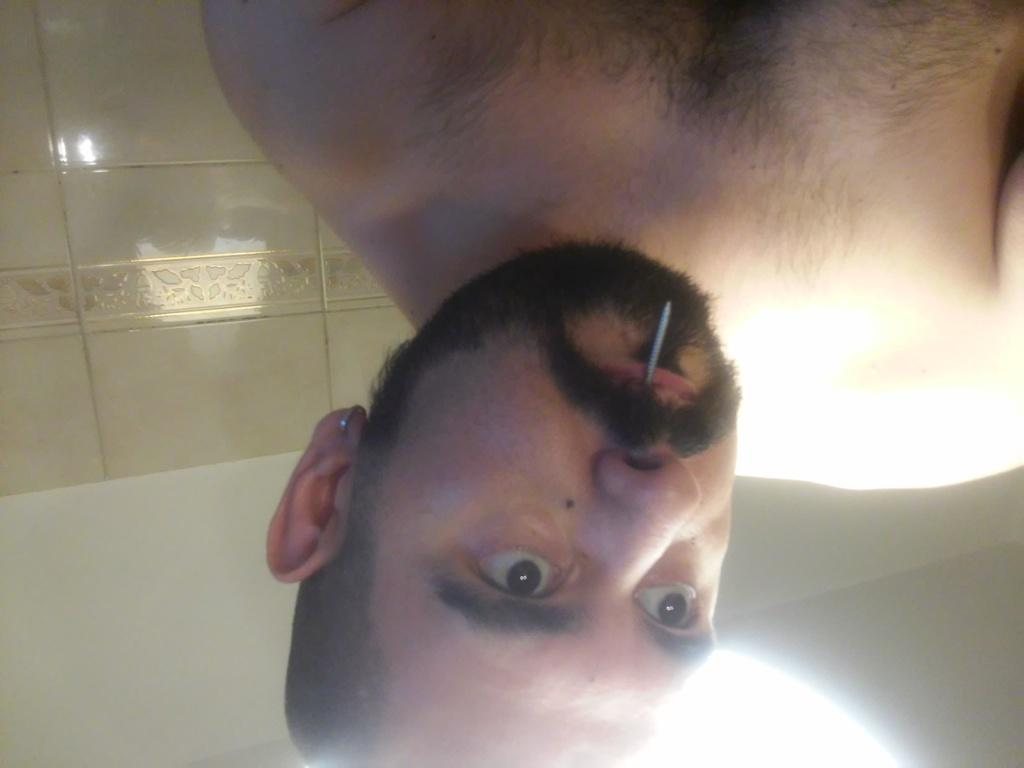What is the main subject of the image? The main subject of the image is a man. What is the man doing in the image? The man is holding a nail with his mouth. What type of vegetable is the man holding in the image? The man is not holding a vegetable in the image; he is holding a nail with his mouth. 